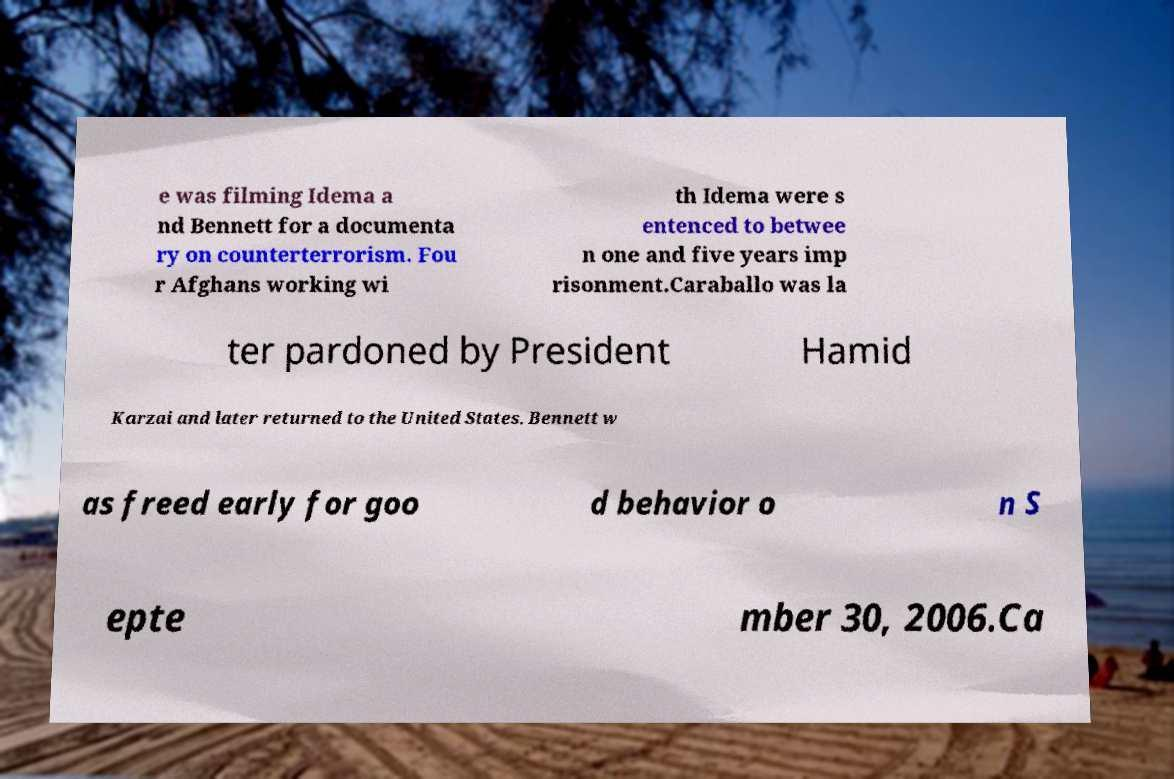There's text embedded in this image that I need extracted. Can you transcribe it verbatim? e was filming Idema a nd Bennett for a documenta ry on counterterrorism. Fou r Afghans working wi th Idema were s entenced to betwee n one and five years imp risonment.Caraballo was la ter pardoned by President Hamid Karzai and later returned to the United States. Bennett w as freed early for goo d behavior o n S epte mber 30, 2006.Ca 